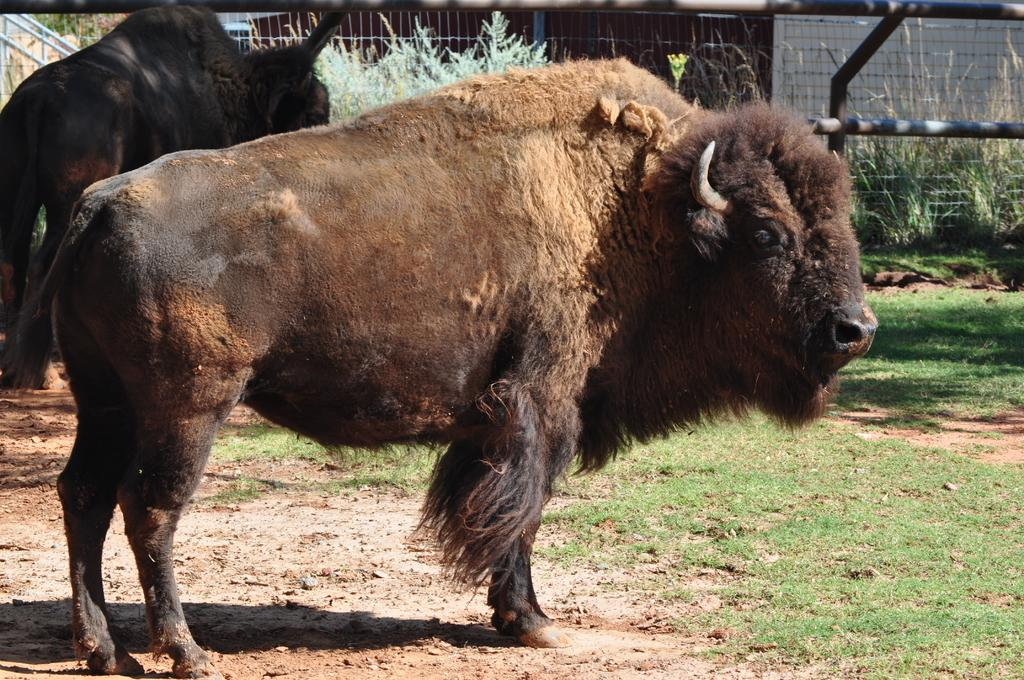What type of animals can be seen in the image? There are two bison-like animals in the image. What can be used for cooking in the image? There are grills in the image. What material are some objects made of in the image? There are metal objects in the image. What type of vegetation is present in the image? There is grass and plants in the image. What type of cracker is being used to scare away the bison-like animals in the image? There is no cracker present in the image, nor is there any indication that the animals are being scared away. 